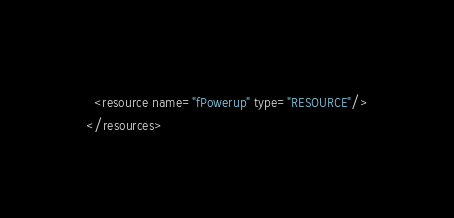Convert code to text. <code><loc_0><loc_0><loc_500><loc_500><_XML_>  <resource name="fPowerup" type="RESOURCE"/>
</resources>
</code> 